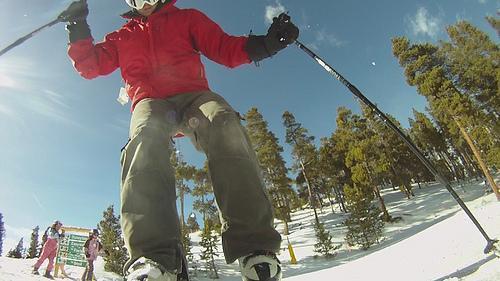How many people are in this picture?
Give a very brief answer. 3. 